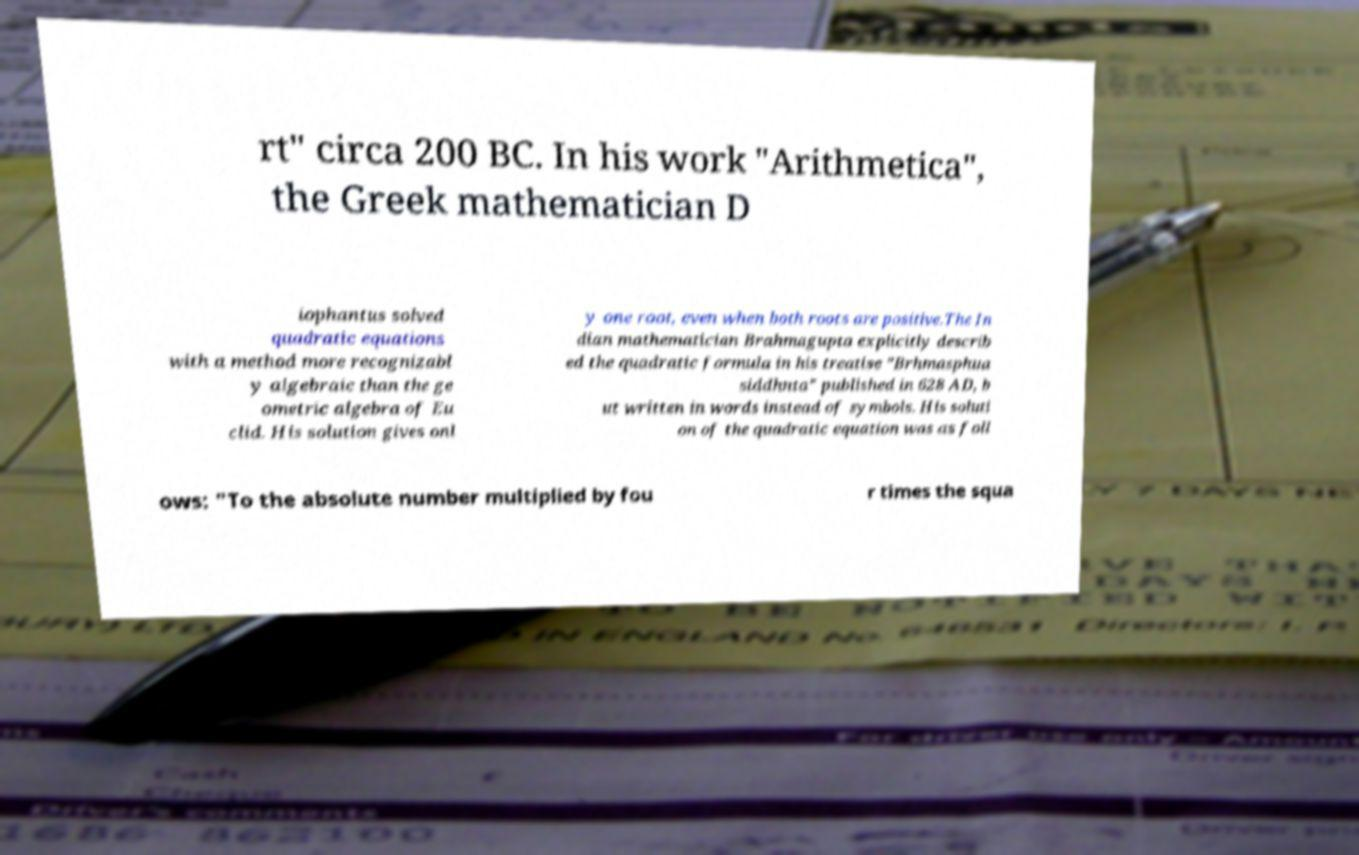Could you assist in decoding the text presented in this image and type it out clearly? rt" circa 200 BC. In his work "Arithmetica", the Greek mathematician D iophantus solved quadratic equations with a method more recognizabl y algebraic than the ge ometric algebra of Eu clid. His solution gives onl y one root, even when both roots are positive.The In dian mathematician Brahmagupta explicitly describ ed the quadratic formula in his treatise "Brhmasphua siddhnta" published in 628 AD, b ut written in words instead of symbols. His soluti on of the quadratic equation was as foll ows: "To the absolute number multiplied by fou r times the squa 